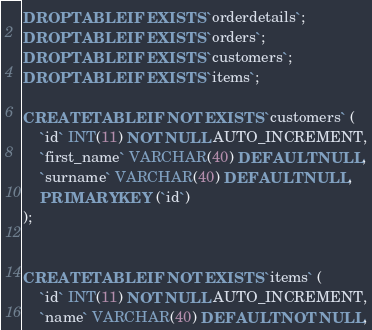<code> <loc_0><loc_0><loc_500><loc_500><_SQL_>DROP TABLE IF EXISTS `orderdetails`;
DROP TABLE IF EXISTS `orders`;
DROP TABLE IF EXISTS `customers`;
DROP TABLE IF EXISTS `items`;

CREATE TABLE IF NOT EXISTS `customers` (
    `id` INT(11) NOT NULL AUTO_INCREMENT,
    `first_name` VARCHAR(40) DEFAULT NULL,
    `surname` VARCHAR(40) DEFAULT NULL,
    PRIMARY KEY (`id`)
);


CREATE TABLE IF NOT EXISTS `items` (
    `id` INT(11) NOT NULL AUTO_INCREMENT,
	`name` VARCHAR(40) DEFAULT NOT NULL,</code> 